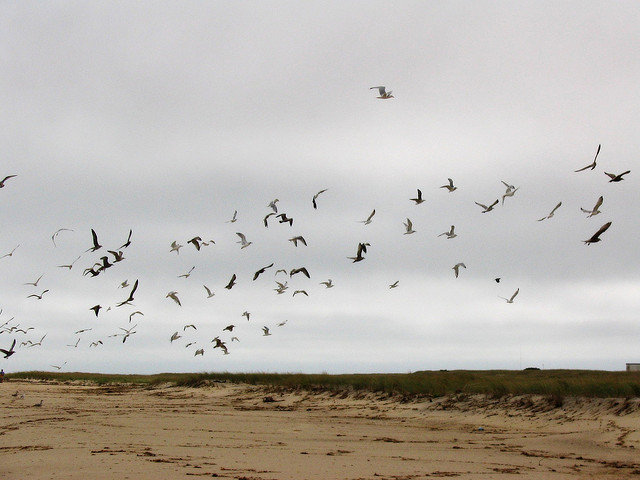<image>Has anyone else been on this beach today? I don't know if anyone else has been on this beach today. It could be both yes and no. What kind of birds are these? I'm not certain about the kind of birds in the image. They could be seagulls or gulls. Has anyone else been on this beach today? I am not sure if anyone else has been on this beach today. It can be both yes or no. What kind of birds are these? I am not sure what kind of birds these are. It can be seen as 'gulls' or 'seagulls'. 